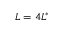<formula> <loc_0><loc_0><loc_500><loc_500>L = 4 L ^ { * }</formula> 